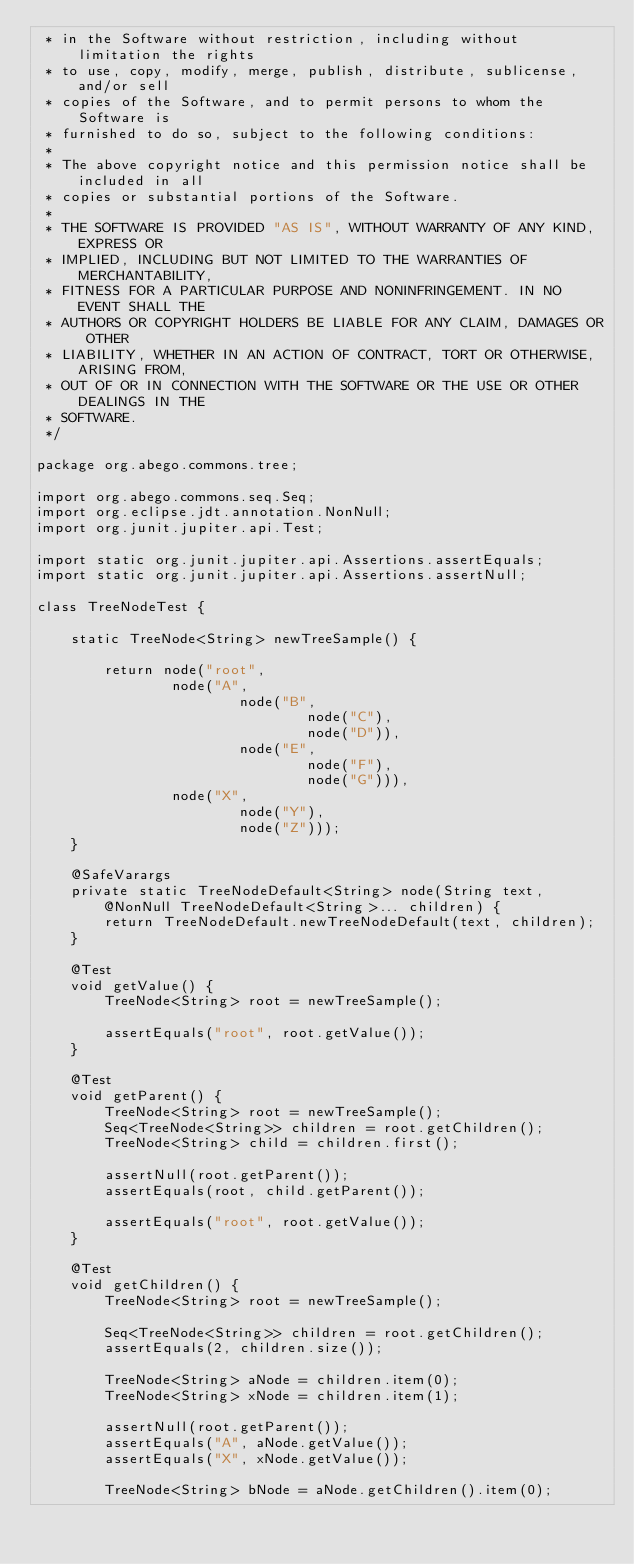Convert code to text. <code><loc_0><loc_0><loc_500><loc_500><_Java_> * in the Software without restriction, including without limitation the rights
 * to use, copy, modify, merge, publish, distribute, sublicense, and/or sell
 * copies of the Software, and to permit persons to whom the Software is
 * furnished to do so, subject to the following conditions:
 *
 * The above copyright notice and this permission notice shall be included in all
 * copies or substantial portions of the Software.
 *
 * THE SOFTWARE IS PROVIDED "AS IS", WITHOUT WARRANTY OF ANY KIND, EXPRESS OR
 * IMPLIED, INCLUDING BUT NOT LIMITED TO THE WARRANTIES OF MERCHANTABILITY,
 * FITNESS FOR A PARTICULAR PURPOSE AND NONINFRINGEMENT. IN NO EVENT SHALL THE
 * AUTHORS OR COPYRIGHT HOLDERS BE LIABLE FOR ANY CLAIM, DAMAGES OR OTHER
 * LIABILITY, WHETHER IN AN ACTION OF CONTRACT, TORT OR OTHERWISE, ARISING FROM,
 * OUT OF OR IN CONNECTION WITH THE SOFTWARE OR THE USE OR OTHER DEALINGS IN THE
 * SOFTWARE.
 */

package org.abego.commons.tree;

import org.abego.commons.seq.Seq;
import org.eclipse.jdt.annotation.NonNull;
import org.junit.jupiter.api.Test;

import static org.junit.jupiter.api.Assertions.assertEquals;
import static org.junit.jupiter.api.Assertions.assertNull;

class TreeNodeTest {

    static TreeNode<String> newTreeSample() {

        return node("root",
                node("A",
                        node("B",
                                node("C"),
                                node("D")),
                        node("E",
                                node("F"),
                                node("G"))),
                node("X",
                        node("Y"),
                        node("Z")));
    }

    @SafeVarargs
    private static TreeNodeDefault<String> node(String text, @NonNull TreeNodeDefault<String>... children) {
        return TreeNodeDefault.newTreeNodeDefault(text, children);
    }

    @Test
    void getValue() {
        TreeNode<String> root = newTreeSample();

        assertEquals("root", root.getValue());
    }

    @Test
    void getParent() {
        TreeNode<String> root = newTreeSample();
        Seq<TreeNode<String>> children = root.getChildren();
        TreeNode<String> child = children.first();

        assertNull(root.getParent());
        assertEquals(root, child.getParent());

        assertEquals("root", root.getValue());
    }

    @Test
    void getChildren() {
        TreeNode<String> root = newTreeSample();

        Seq<TreeNode<String>> children = root.getChildren();
        assertEquals(2, children.size());

        TreeNode<String> aNode = children.item(0);
        TreeNode<String> xNode = children.item(1);

        assertNull(root.getParent());
        assertEquals("A", aNode.getValue());
        assertEquals("X", xNode.getValue());

        TreeNode<String> bNode = aNode.getChildren().item(0);</code> 